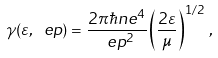Convert formula to latex. <formula><loc_0><loc_0><loc_500><loc_500>\gamma ( \varepsilon , \ e p ) = \frac { 2 \pi \hbar { n } e ^ { 4 } } { \ e p ^ { 2 } } \left ( \frac { 2 \varepsilon } { \mu } \right ) ^ { 1 / 2 } \, ,</formula> 